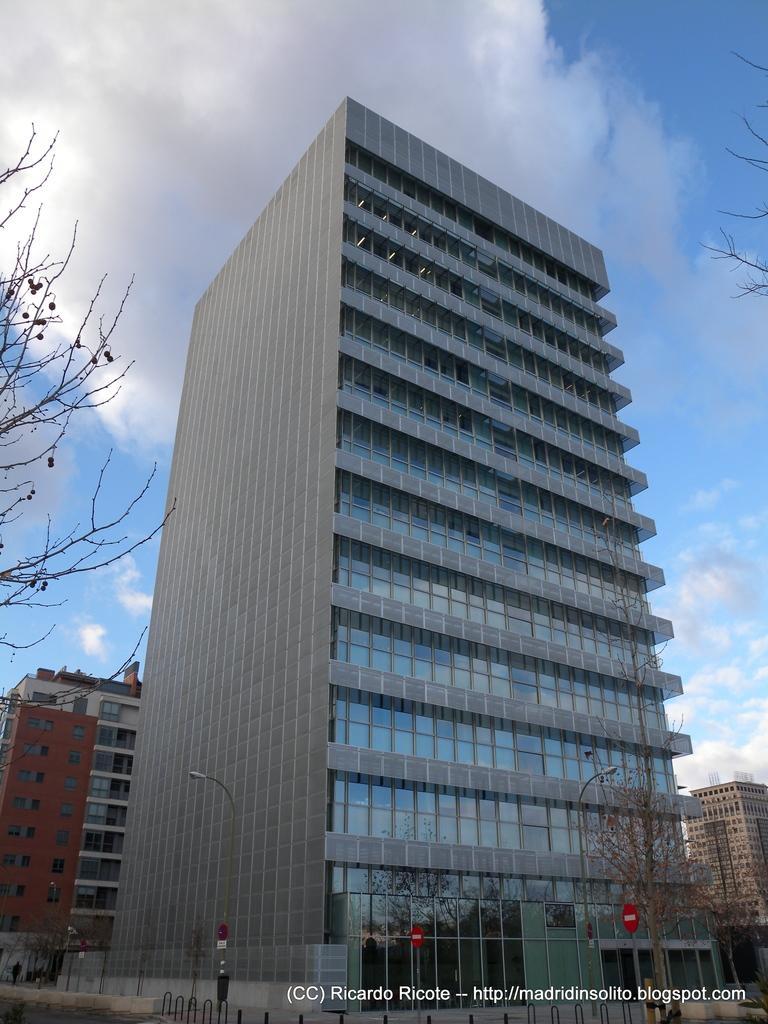Could you give a brief overview of what you see in this image? In this picture I can see buildings, trees and I can see text at the bottom right corner of the picture and I can see blue cloudy sky. 